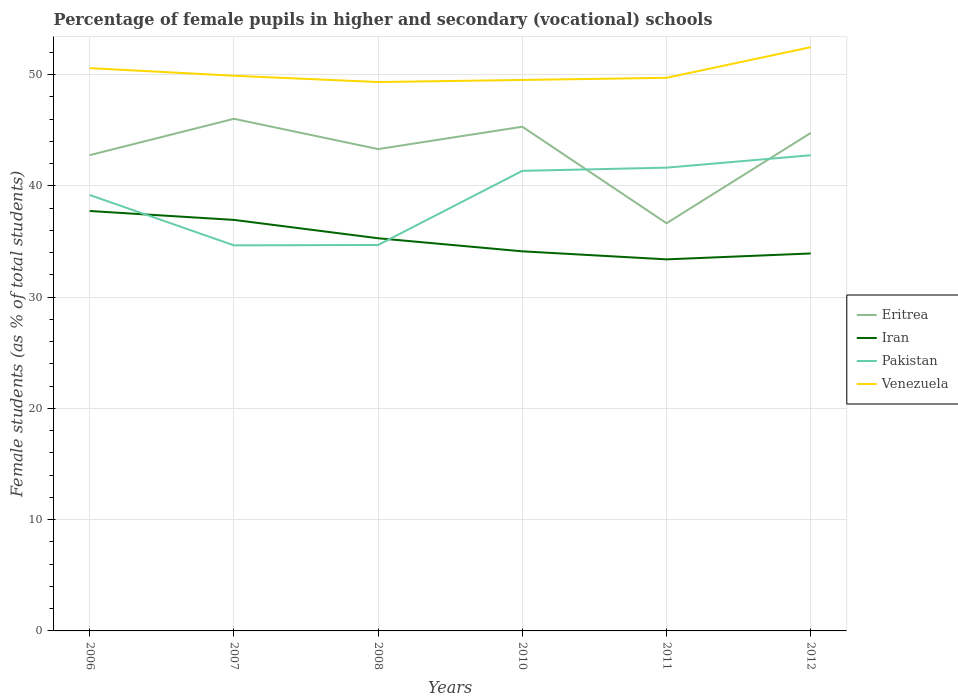Is the number of lines equal to the number of legend labels?
Provide a succinct answer. Yes. Across all years, what is the maximum percentage of female pupils in higher and secondary schools in Venezuela?
Ensure brevity in your answer.  49.34. In which year was the percentage of female pupils in higher and secondary schools in Iran maximum?
Provide a succinct answer. 2011. What is the total percentage of female pupils in higher and secondary schools in Eritrea in the graph?
Your answer should be very brief. 9.39. What is the difference between the highest and the second highest percentage of female pupils in higher and secondary schools in Venezuela?
Offer a terse response. 3.13. What is the difference between the highest and the lowest percentage of female pupils in higher and secondary schools in Eritrea?
Ensure brevity in your answer.  4. How many years are there in the graph?
Offer a very short reply. 6. Does the graph contain any zero values?
Give a very brief answer. No. How are the legend labels stacked?
Make the answer very short. Vertical. What is the title of the graph?
Your answer should be very brief. Percentage of female pupils in higher and secondary (vocational) schools. What is the label or title of the X-axis?
Offer a terse response. Years. What is the label or title of the Y-axis?
Make the answer very short. Female students (as % of total students). What is the Female students (as % of total students) in Eritrea in 2006?
Give a very brief answer. 42.77. What is the Female students (as % of total students) of Iran in 2006?
Provide a succinct answer. 37.75. What is the Female students (as % of total students) of Pakistan in 2006?
Keep it short and to the point. 39.18. What is the Female students (as % of total students) in Venezuela in 2006?
Your answer should be very brief. 50.59. What is the Female students (as % of total students) in Eritrea in 2007?
Your answer should be compact. 46.03. What is the Female students (as % of total students) in Iran in 2007?
Offer a very short reply. 36.95. What is the Female students (as % of total students) in Pakistan in 2007?
Your answer should be very brief. 34.66. What is the Female students (as % of total students) in Venezuela in 2007?
Give a very brief answer. 49.91. What is the Female students (as % of total students) in Eritrea in 2008?
Your answer should be very brief. 43.31. What is the Female students (as % of total students) of Iran in 2008?
Your response must be concise. 35.3. What is the Female students (as % of total students) in Pakistan in 2008?
Your answer should be compact. 34.69. What is the Female students (as % of total students) of Venezuela in 2008?
Make the answer very short. 49.34. What is the Female students (as % of total students) in Eritrea in 2010?
Your response must be concise. 45.32. What is the Female students (as % of total students) of Iran in 2010?
Your response must be concise. 34.12. What is the Female students (as % of total students) of Pakistan in 2010?
Your answer should be very brief. 41.36. What is the Female students (as % of total students) in Venezuela in 2010?
Your answer should be very brief. 49.53. What is the Female students (as % of total students) in Eritrea in 2011?
Your response must be concise. 36.65. What is the Female students (as % of total students) in Iran in 2011?
Provide a short and direct response. 33.4. What is the Female students (as % of total students) in Pakistan in 2011?
Give a very brief answer. 41.64. What is the Female students (as % of total students) in Venezuela in 2011?
Provide a short and direct response. 49.72. What is the Female students (as % of total students) in Eritrea in 2012?
Give a very brief answer. 44.76. What is the Female students (as % of total students) in Iran in 2012?
Keep it short and to the point. 33.93. What is the Female students (as % of total students) of Pakistan in 2012?
Your response must be concise. 42.76. What is the Female students (as % of total students) of Venezuela in 2012?
Keep it short and to the point. 52.47. Across all years, what is the maximum Female students (as % of total students) of Eritrea?
Provide a succinct answer. 46.03. Across all years, what is the maximum Female students (as % of total students) of Iran?
Offer a terse response. 37.75. Across all years, what is the maximum Female students (as % of total students) in Pakistan?
Your answer should be compact. 42.76. Across all years, what is the maximum Female students (as % of total students) in Venezuela?
Keep it short and to the point. 52.47. Across all years, what is the minimum Female students (as % of total students) of Eritrea?
Give a very brief answer. 36.65. Across all years, what is the minimum Female students (as % of total students) of Iran?
Your answer should be compact. 33.4. Across all years, what is the minimum Female students (as % of total students) of Pakistan?
Provide a succinct answer. 34.66. Across all years, what is the minimum Female students (as % of total students) of Venezuela?
Your answer should be very brief. 49.34. What is the total Female students (as % of total students) in Eritrea in the graph?
Provide a succinct answer. 258.84. What is the total Female students (as % of total students) of Iran in the graph?
Offer a terse response. 211.44. What is the total Female students (as % of total students) in Pakistan in the graph?
Provide a succinct answer. 234.29. What is the total Female students (as % of total students) in Venezuela in the graph?
Offer a very short reply. 301.55. What is the difference between the Female students (as % of total students) of Eritrea in 2006 and that in 2007?
Offer a terse response. -3.27. What is the difference between the Female students (as % of total students) of Iran in 2006 and that in 2007?
Offer a terse response. 0.8. What is the difference between the Female students (as % of total students) in Pakistan in 2006 and that in 2007?
Provide a succinct answer. 4.53. What is the difference between the Female students (as % of total students) of Venezuela in 2006 and that in 2007?
Offer a very short reply. 0.68. What is the difference between the Female students (as % of total students) in Eritrea in 2006 and that in 2008?
Ensure brevity in your answer.  -0.54. What is the difference between the Female students (as % of total students) of Iran in 2006 and that in 2008?
Your answer should be compact. 2.45. What is the difference between the Female students (as % of total students) in Pakistan in 2006 and that in 2008?
Provide a short and direct response. 4.49. What is the difference between the Female students (as % of total students) in Venezuela in 2006 and that in 2008?
Offer a terse response. 1.25. What is the difference between the Female students (as % of total students) of Eritrea in 2006 and that in 2010?
Your answer should be very brief. -2.56. What is the difference between the Female students (as % of total students) of Iran in 2006 and that in 2010?
Your answer should be compact. 3.63. What is the difference between the Female students (as % of total students) in Pakistan in 2006 and that in 2010?
Your answer should be very brief. -2.17. What is the difference between the Female students (as % of total students) in Venezuela in 2006 and that in 2010?
Give a very brief answer. 1.06. What is the difference between the Female students (as % of total students) of Eritrea in 2006 and that in 2011?
Give a very brief answer. 6.12. What is the difference between the Female students (as % of total students) in Iran in 2006 and that in 2011?
Keep it short and to the point. 4.35. What is the difference between the Female students (as % of total students) in Pakistan in 2006 and that in 2011?
Keep it short and to the point. -2.46. What is the difference between the Female students (as % of total students) in Venezuela in 2006 and that in 2011?
Your response must be concise. 0.87. What is the difference between the Female students (as % of total students) of Eritrea in 2006 and that in 2012?
Offer a terse response. -1.99. What is the difference between the Female students (as % of total students) of Iran in 2006 and that in 2012?
Your answer should be very brief. 3.82. What is the difference between the Female students (as % of total students) of Pakistan in 2006 and that in 2012?
Offer a very short reply. -3.57. What is the difference between the Female students (as % of total students) of Venezuela in 2006 and that in 2012?
Your answer should be compact. -1.88. What is the difference between the Female students (as % of total students) in Eritrea in 2007 and that in 2008?
Keep it short and to the point. 2.72. What is the difference between the Female students (as % of total students) in Iran in 2007 and that in 2008?
Give a very brief answer. 1.65. What is the difference between the Female students (as % of total students) in Pakistan in 2007 and that in 2008?
Keep it short and to the point. -0.04. What is the difference between the Female students (as % of total students) in Venezuela in 2007 and that in 2008?
Your answer should be compact. 0.57. What is the difference between the Female students (as % of total students) in Eritrea in 2007 and that in 2010?
Ensure brevity in your answer.  0.71. What is the difference between the Female students (as % of total students) in Iran in 2007 and that in 2010?
Give a very brief answer. 2.82. What is the difference between the Female students (as % of total students) in Pakistan in 2007 and that in 2010?
Your answer should be compact. -6.7. What is the difference between the Female students (as % of total students) in Venezuela in 2007 and that in 2010?
Your answer should be very brief. 0.38. What is the difference between the Female students (as % of total students) in Eritrea in 2007 and that in 2011?
Provide a short and direct response. 9.39. What is the difference between the Female students (as % of total students) of Iran in 2007 and that in 2011?
Give a very brief answer. 3.55. What is the difference between the Female students (as % of total students) of Pakistan in 2007 and that in 2011?
Your answer should be compact. -6.99. What is the difference between the Female students (as % of total students) in Venezuela in 2007 and that in 2011?
Provide a short and direct response. 0.19. What is the difference between the Female students (as % of total students) in Eritrea in 2007 and that in 2012?
Provide a succinct answer. 1.27. What is the difference between the Female students (as % of total students) of Iran in 2007 and that in 2012?
Offer a terse response. 3.02. What is the difference between the Female students (as % of total students) of Pakistan in 2007 and that in 2012?
Offer a very short reply. -8.1. What is the difference between the Female students (as % of total students) of Venezuela in 2007 and that in 2012?
Provide a succinct answer. -2.57. What is the difference between the Female students (as % of total students) of Eritrea in 2008 and that in 2010?
Provide a short and direct response. -2.01. What is the difference between the Female students (as % of total students) in Iran in 2008 and that in 2010?
Offer a terse response. 1.17. What is the difference between the Female students (as % of total students) of Pakistan in 2008 and that in 2010?
Your response must be concise. -6.66. What is the difference between the Female students (as % of total students) of Venezuela in 2008 and that in 2010?
Offer a terse response. -0.19. What is the difference between the Female students (as % of total students) in Eritrea in 2008 and that in 2011?
Your answer should be compact. 6.66. What is the difference between the Female students (as % of total students) of Iran in 2008 and that in 2011?
Make the answer very short. 1.9. What is the difference between the Female students (as % of total students) in Pakistan in 2008 and that in 2011?
Provide a short and direct response. -6.95. What is the difference between the Female students (as % of total students) in Venezuela in 2008 and that in 2011?
Offer a terse response. -0.38. What is the difference between the Female students (as % of total students) in Eritrea in 2008 and that in 2012?
Your answer should be very brief. -1.45. What is the difference between the Female students (as % of total students) in Iran in 2008 and that in 2012?
Provide a short and direct response. 1.37. What is the difference between the Female students (as % of total students) in Pakistan in 2008 and that in 2012?
Ensure brevity in your answer.  -8.07. What is the difference between the Female students (as % of total students) in Venezuela in 2008 and that in 2012?
Your answer should be compact. -3.13. What is the difference between the Female students (as % of total students) of Eritrea in 2010 and that in 2011?
Keep it short and to the point. 8.68. What is the difference between the Female students (as % of total students) in Iran in 2010 and that in 2011?
Offer a very short reply. 0.72. What is the difference between the Female students (as % of total students) of Pakistan in 2010 and that in 2011?
Your answer should be very brief. -0.29. What is the difference between the Female students (as % of total students) in Venezuela in 2010 and that in 2011?
Your answer should be compact. -0.19. What is the difference between the Female students (as % of total students) of Eritrea in 2010 and that in 2012?
Give a very brief answer. 0.56. What is the difference between the Female students (as % of total students) in Iran in 2010 and that in 2012?
Make the answer very short. 0.19. What is the difference between the Female students (as % of total students) in Pakistan in 2010 and that in 2012?
Your answer should be compact. -1.4. What is the difference between the Female students (as % of total students) in Venezuela in 2010 and that in 2012?
Your answer should be compact. -2.95. What is the difference between the Female students (as % of total students) in Eritrea in 2011 and that in 2012?
Provide a short and direct response. -8.12. What is the difference between the Female students (as % of total students) in Iran in 2011 and that in 2012?
Provide a short and direct response. -0.53. What is the difference between the Female students (as % of total students) of Pakistan in 2011 and that in 2012?
Your answer should be very brief. -1.12. What is the difference between the Female students (as % of total students) in Venezuela in 2011 and that in 2012?
Give a very brief answer. -2.75. What is the difference between the Female students (as % of total students) of Eritrea in 2006 and the Female students (as % of total students) of Iran in 2007?
Provide a short and direct response. 5.82. What is the difference between the Female students (as % of total students) of Eritrea in 2006 and the Female students (as % of total students) of Pakistan in 2007?
Ensure brevity in your answer.  8.11. What is the difference between the Female students (as % of total students) of Eritrea in 2006 and the Female students (as % of total students) of Venezuela in 2007?
Ensure brevity in your answer.  -7.14. What is the difference between the Female students (as % of total students) of Iran in 2006 and the Female students (as % of total students) of Pakistan in 2007?
Give a very brief answer. 3.09. What is the difference between the Female students (as % of total students) of Iran in 2006 and the Female students (as % of total students) of Venezuela in 2007?
Ensure brevity in your answer.  -12.16. What is the difference between the Female students (as % of total students) in Pakistan in 2006 and the Female students (as % of total students) in Venezuela in 2007?
Provide a succinct answer. -10.72. What is the difference between the Female students (as % of total students) of Eritrea in 2006 and the Female students (as % of total students) of Iran in 2008?
Provide a succinct answer. 7.47. What is the difference between the Female students (as % of total students) of Eritrea in 2006 and the Female students (as % of total students) of Pakistan in 2008?
Give a very brief answer. 8.07. What is the difference between the Female students (as % of total students) of Eritrea in 2006 and the Female students (as % of total students) of Venezuela in 2008?
Give a very brief answer. -6.57. What is the difference between the Female students (as % of total students) in Iran in 2006 and the Female students (as % of total students) in Pakistan in 2008?
Make the answer very short. 3.05. What is the difference between the Female students (as % of total students) in Iran in 2006 and the Female students (as % of total students) in Venezuela in 2008?
Ensure brevity in your answer.  -11.59. What is the difference between the Female students (as % of total students) in Pakistan in 2006 and the Female students (as % of total students) in Venezuela in 2008?
Offer a very short reply. -10.15. What is the difference between the Female students (as % of total students) in Eritrea in 2006 and the Female students (as % of total students) in Iran in 2010?
Provide a succinct answer. 8.65. What is the difference between the Female students (as % of total students) in Eritrea in 2006 and the Female students (as % of total students) in Pakistan in 2010?
Offer a terse response. 1.41. What is the difference between the Female students (as % of total students) of Eritrea in 2006 and the Female students (as % of total students) of Venezuela in 2010?
Your answer should be compact. -6.76. What is the difference between the Female students (as % of total students) of Iran in 2006 and the Female students (as % of total students) of Pakistan in 2010?
Your answer should be compact. -3.61. What is the difference between the Female students (as % of total students) in Iran in 2006 and the Female students (as % of total students) in Venezuela in 2010?
Give a very brief answer. -11.78. What is the difference between the Female students (as % of total students) of Pakistan in 2006 and the Female students (as % of total students) of Venezuela in 2010?
Keep it short and to the point. -10.34. What is the difference between the Female students (as % of total students) in Eritrea in 2006 and the Female students (as % of total students) in Iran in 2011?
Offer a terse response. 9.37. What is the difference between the Female students (as % of total students) of Eritrea in 2006 and the Female students (as % of total students) of Pakistan in 2011?
Your response must be concise. 1.12. What is the difference between the Female students (as % of total students) in Eritrea in 2006 and the Female students (as % of total students) in Venezuela in 2011?
Offer a terse response. -6.95. What is the difference between the Female students (as % of total students) of Iran in 2006 and the Female students (as % of total students) of Pakistan in 2011?
Give a very brief answer. -3.9. What is the difference between the Female students (as % of total students) of Iran in 2006 and the Female students (as % of total students) of Venezuela in 2011?
Your answer should be compact. -11.97. What is the difference between the Female students (as % of total students) in Pakistan in 2006 and the Female students (as % of total students) in Venezuela in 2011?
Your response must be concise. -10.53. What is the difference between the Female students (as % of total students) in Eritrea in 2006 and the Female students (as % of total students) in Iran in 2012?
Ensure brevity in your answer.  8.84. What is the difference between the Female students (as % of total students) of Eritrea in 2006 and the Female students (as % of total students) of Pakistan in 2012?
Provide a succinct answer. 0.01. What is the difference between the Female students (as % of total students) in Eritrea in 2006 and the Female students (as % of total students) in Venezuela in 2012?
Your response must be concise. -9.7. What is the difference between the Female students (as % of total students) in Iran in 2006 and the Female students (as % of total students) in Pakistan in 2012?
Your answer should be very brief. -5.01. What is the difference between the Female students (as % of total students) of Iran in 2006 and the Female students (as % of total students) of Venezuela in 2012?
Keep it short and to the point. -14.73. What is the difference between the Female students (as % of total students) of Pakistan in 2006 and the Female students (as % of total students) of Venezuela in 2012?
Your answer should be very brief. -13.29. What is the difference between the Female students (as % of total students) of Eritrea in 2007 and the Female students (as % of total students) of Iran in 2008?
Provide a short and direct response. 10.74. What is the difference between the Female students (as % of total students) in Eritrea in 2007 and the Female students (as % of total students) in Pakistan in 2008?
Make the answer very short. 11.34. What is the difference between the Female students (as % of total students) of Eritrea in 2007 and the Female students (as % of total students) of Venezuela in 2008?
Make the answer very short. -3.3. What is the difference between the Female students (as % of total students) in Iran in 2007 and the Female students (as % of total students) in Pakistan in 2008?
Keep it short and to the point. 2.25. What is the difference between the Female students (as % of total students) in Iran in 2007 and the Female students (as % of total students) in Venezuela in 2008?
Your answer should be very brief. -12.39. What is the difference between the Female students (as % of total students) in Pakistan in 2007 and the Female students (as % of total students) in Venezuela in 2008?
Ensure brevity in your answer.  -14.68. What is the difference between the Female students (as % of total students) of Eritrea in 2007 and the Female students (as % of total students) of Iran in 2010?
Offer a very short reply. 11.91. What is the difference between the Female students (as % of total students) in Eritrea in 2007 and the Female students (as % of total students) in Pakistan in 2010?
Make the answer very short. 4.68. What is the difference between the Female students (as % of total students) in Eritrea in 2007 and the Female students (as % of total students) in Venezuela in 2010?
Offer a very short reply. -3.49. What is the difference between the Female students (as % of total students) in Iran in 2007 and the Female students (as % of total students) in Pakistan in 2010?
Keep it short and to the point. -4.41. What is the difference between the Female students (as % of total students) in Iran in 2007 and the Female students (as % of total students) in Venezuela in 2010?
Offer a very short reply. -12.58. What is the difference between the Female students (as % of total students) in Pakistan in 2007 and the Female students (as % of total students) in Venezuela in 2010?
Your response must be concise. -14.87. What is the difference between the Female students (as % of total students) of Eritrea in 2007 and the Female students (as % of total students) of Iran in 2011?
Your response must be concise. 12.64. What is the difference between the Female students (as % of total students) in Eritrea in 2007 and the Female students (as % of total students) in Pakistan in 2011?
Make the answer very short. 4.39. What is the difference between the Female students (as % of total students) in Eritrea in 2007 and the Female students (as % of total students) in Venezuela in 2011?
Your answer should be very brief. -3.68. What is the difference between the Female students (as % of total students) in Iran in 2007 and the Female students (as % of total students) in Pakistan in 2011?
Make the answer very short. -4.7. What is the difference between the Female students (as % of total students) of Iran in 2007 and the Female students (as % of total students) of Venezuela in 2011?
Your answer should be compact. -12.77. What is the difference between the Female students (as % of total students) in Pakistan in 2007 and the Female students (as % of total students) in Venezuela in 2011?
Offer a terse response. -15.06. What is the difference between the Female students (as % of total students) in Eritrea in 2007 and the Female students (as % of total students) in Iran in 2012?
Offer a terse response. 12.11. What is the difference between the Female students (as % of total students) of Eritrea in 2007 and the Female students (as % of total students) of Pakistan in 2012?
Ensure brevity in your answer.  3.28. What is the difference between the Female students (as % of total students) of Eritrea in 2007 and the Female students (as % of total students) of Venezuela in 2012?
Your response must be concise. -6.44. What is the difference between the Female students (as % of total students) of Iran in 2007 and the Female students (as % of total students) of Pakistan in 2012?
Provide a short and direct response. -5.81. What is the difference between the Female students (as % of total students) in Iran in 2007 and the Female students (as % of total students) in Venezuela in 2012?
Provide a succinct answer. -15.53. What is the difference between the Female students (as % of total students) in Pakistan in 2007 and the Female students (as % of total students) in Venezuela in 2012?
Your answer should be very brief. -17.81. What is the difference between the Female students (as % of total students) in Eritrea in 2008 and the Female students (as % of total students) in Iran in 2010?
Your answer should be compact. 9.19. What is the difference between the Female students (as % of total students) of Eritrea in 2008 and the Female students (as % of total students) of Pakistan in 2010?
Your response must be concise. 1.96. What is the difference between the Female students (as % of total students) of Eritrea in 2008 and the Female students (as % of total students) of Venezuela in 2010?
Offer a terse response. -6.21. What is the difference between the Female students (as % of total students) in Iran in 2008 and the Female students (as % of total students) in Pakistan in 2010?
Your response must be concise. -6.06. What is the difference between the Female students (as % of total students) in Iran in 2008 and the Female students (as % of total students) in Venezuela in 2010?
Ensure brevity in your answer.  -14.23. What is the difference between the Female students (as % of total students) in Pakistan in 2008 and the Female students (as % of total students) in Venezuela in 2010?
Offer a terse response. -14.83. What is the difference between the Female students (as % of total students) of Eritrea in 2008 and the Female students (as % of total students) of Iran in 2011?
Provide a short and direct response. 9.91. What is the difference between the Female students (as % of total students) in Eritrea in 2008 and the Female students (as % of total students) in Pakistan in 2011?
Your answer should be very brief. 1.67. What is the difference between the Female students (as % of total students) of Eritrea in 2008 and the Female students (as % of total students) of Venezuela in 2011?
Provide a short and direct response. -6.41. What is the difference between the Female students (as % of total students) of Iran in 2008 and the Female students (as % of total students) of Pakistan in 2011?
Provide a short and direct response. -6.35. What is the difference between the Female students (as % of total students) of Iran in 2008 and the Female students (as % of total students) of Venezuela in 2011?
Keep it short and to the point. -14.42. What is the difference between the Female students (as % of total students) of Pakistan in 2008 and the Female students (as % of total students) of Venezuela in 2011?
Ensure brevity in your answer.  -15.03. What is the difference between the Female students (as % of total students) of Eritrea in 2008 and the Female students (as % of total students) of Iran in 2012?
Your response must be concise. 9.38. What is the difference between the Female students (as % of total students) of Eritrea in 2008 and the Female students (as % of total students) of Pakistan in 2012?
Offer a very short reply. 0.55. What is the difference between the Female students (as % of total students) of Eritrea in 2008 and the Female students (as % of total students) of Venezuela in 2012?
Offer a very short reply. -9.16. What is the difference between the Female students (as % of total students) of Iran in 2008 and the Female students (as % of total students) of Pakistan in 2012?
Make the answer very short. -7.46. What is the difference between the Female students (as % of total students) in Iran in 2008 and the Female students (as % of total students) in Venezuela in 2012?
Make the answer very short. -17.18. What is the difference between the Female students (as % of total students) in Pakistan in 2008 and the Female students (as % of total students) in Venezuela in 2012?
Your answer should be very brief. -17.78. What is the difference between the Female students (as % of total students) in Eritrea in 2010 and the Female students (as % of total students) in Iran in 2011?
Keep it short and to the point. 11.92. What is the difference between the Female students (as % of total students) in Eritrea in 2010 and the Female students (as % of total students) in Pakistan in 2011?
Give a very brief answer. 3.68. What is the difference between the Female students (as % of total students) of Eritrea in 2010 and the Female students (as % of total students) of Venezuela in 2011?
Your answer should be very brief. -4.4. What is the difference between the Female students (as % of total students) in Iran in 2010 and the Female students (as % of total students) in Pakistan in 2011?
Keep it short and to the point. -7.52. What is the difference between the Female students (as % of total students) in Iran in 2010 and the Female students (as % of total students) in Venezuela in 2011?
Provide a short and direct response. -15.6. What is the difference between the Female students (as % of total students) of Pakistan in 2010 and the Female students (as % of total students) of Venezuela in 2011?
Provide a succinct answer. -8.36. What is the difference between the Female students (as % of total students) of Eritrea in 2010 and the Female students (as % of total students) of Iran in 2012?
Your answer should be very brief. 11.39. What is the difference between the Female students (as % of total students) of Eritrea in 2010 and the Female students (as % of total students) of Pakistan in 2012?
Offer a terse response. 2.56. What is the difference between the Female students (as % of total students) in Eritrea in 2010 and the Female students (as % of total students) in Venezuela in 2012?
Make the answer very short. -7.15. What is the difference between the Female students (as % of total students) of Iran in 2010 and the Female students (as % of total students) of Pakistan in 2012?
Your response must be concise. -8.64. What is the difference between the Female students (as % of total students) in Iran in 2010 and the Female students (as % of total students) in Venezuela in 2012?
Make the answer very short. -18.35. What is the difference between the Female students (as % of total students) in Pakistan in 2010 and the Female students (as % of total students) in Venezuela in 2012?
Keep it short and to the point. -11.12. What is the difference between the Female students (as % of total students) of Eritrea in 2011 and the Female students (as % of total students) of Iran in 2012?
Your response must be concise. 2.72. What is the difference between the Female students (as % of total students) in Eritrea in 2011 and the Female students (as % of total students) in Pakistan in 2012?
Make the answer very short. -6.11. What is the difference between the Female students (as % of total students) of Eritrea in 2011 and the Female students (as % of total students) of Venezuela in 2012?
Your answer should be compact. -15.82. What is the difference between the Female students (as % of total students) of Iran in 2011 and the Female students (as % of total students) of Pakistan in 2012?
Provide a short and direct response. -9.36. What is the difference between the Female students (as % of total students) in Iran in 2011 and the Female students (as % of total students) in Venezuela in 2012?
Offer a very short reply. -19.07. What is the difference between the Female students (as % of total students) of Pakistan in 2011 and the Female students (as % of total students) of Venezuela in 2012?
Your answer should be compact. -10.83. What is the average Female students (as % of total students) in Eritrea per year?
Make the answer very short. 43.14. What is the average Female students (as % of total students) in Iran per year?
Make the answer very short. 35.24. What is the average Female students (as % of total students) of Pakistan per year?
Offer a very short reply. 39.05. What is the average Female students (as % of total students) in Venezuela per year?
Ensure brevity in your answer.  50.26. In the year 2006, what is the difference between the Female students (as % of total students) of Eritrea and Female students (as % of total students) of Iran?
Offer a terse response. 5.02. In the year 2006, what is the difference between the Female students (as % of total students) of Eritrea and Female students (as % of total students) of Pakistan?
Your response must be concise. 3.58. In the year 2006, what is the difference between the Female students (as % of total students) in Eritrea and Female students (as % of total students) in Venezuela?
Provide a short and direct response. -7.82. In the year 2006, what is the difference between the Female students (as % of total students) in Iran and Female students (as % of total students) in Pakistan?
Your answer should be very brief. -1.44. In the year 2006, what is the difference between the Female students (as % of total students) in Iran and Female students (as % of total students) in Venezuela?
Keep it short and to the point. -12.84. In the year 2006, what is the difference between the Female students (as % of total students) in Pakistan and Female students (as % of total students) in Venezuela?
Ensure brevity in your answer.  -11.4. In the year 2007, what is the difference between the Female students (as % of total students) in Eritrea and Female students (as % of total students) in Iran?
Provide a succinct answer. 9.09. In the year 2007, what is the difference between the Female students (as % of total students) of Eritrea and Female students (as % of total students) of Pakistan?
Your response must be concise. 11.38. In the year 2007, what is the difference between the Female students (as % of total students) of Eritrea and Female students (as % of total students) of Venezuela?
Offer a very short reply. -3.87. In the year 2007, what is the difference between the Female students (as % of total students) in Iran and Female students (as % of total students) in Pakistan?
Your answer should be compact. 2.29. In the year 2007, what is the difference between the Female students (as % of total students) in Iran and Female students (as % of total students) in Venezuela?
Provide a succinct answer. -12.96. In the year 2007, what is the difference between the Female students (as % of total students) of Pakistan and Female students (as % of total students) of Venezuela?
Give a very brief answer. -15.25. In the year 2008, what is the difference between the Female students (as % of total students) in Eritrea and Female students (as % of total students) in Iran?
Provide a short and direct response. 8.02. In the year 2008, what is the difference between the Female students (as % of total students) in Eritrea and Female students (as % of total students) in Pakistan?
Your response must be concise. 8.62. In the year 2008, what is the difference between the Female students (as % of total students) in Eritrea and Female students (as % of total students) in Venezuela?
Provide a succinct answer. -6.03. In the year 2008, what is the difference between the Female students (as % of total students) in Iran and Female students (as % of total students) in Pakistan?
Provide a succinct answer. 0.6. In the year 2008, what is the difference between the Female students (as % of total students) in Iran and Female students (as % of total students) in Venezuela?
Ensure brevity in your answer.  -14.04. In the year 2008, what is the difference between the Female students (as % of total students) of Pakistan and Female students (as % of total students) of Venezuela?
Provide a succinct answer. -14.64. In the year 2010, what is the difference between the Female students (as % of total students) of Eritrea and Female students (as % of total students) of Iran?
Provide a short and direct response. 11.2. In the year 2010, what is the difference between the Female students (as % of total students) of Eritrea and Female students (as % of total students) of Pakistan?
Provide a succinct answer. 3.97. In the year 2010, what is the difference between the Female students (as % of total students) in Eritrea and Female students (as % of total students) in Venezuela?
Your answer should be compact. -4.2. In the year 2010, what is the difference between the Female students (as % of total students) in Iran and Female students (as % of total students) in Pakistan?
Your answer should be very brief. -7.23. In the year 2010, what is the difference between the Female students (as % of total students) of Iran and Female students (as % of total students) of Venezuela?
Make the answer very short. -15.41. In the year 2010, what is the difference between the Female students (as % of total students) in Pakistan and Female students (as % of total students) in Venezuela?
Offer a terse response. -8.17. In the year 2011, what is the difference between the Female students (as % of total students) in Eritrea and Female students (as % of total students) in Iran?
Keep it short and to the point. 3.25. In the year 2011, what is the difference between the Female students (as % of total students) of Eritrea and Female students (as % of total students) of Pakistan?
Your answer should be compact. -5. In the year 2011, what is the difference between the Female students (as % of total students) of Eritrea and Female students (as % of total students) of Venezuela?
Your answer should be very brief. -13.07. In the year 2011, what is the difference between the Female students (as % of total students) of Iran and Female students (as % of total students) of Pakistan?
Give a very brief answer. -8.24. In the year 2011, what is the difference between the Female students (as % of total students) of Iran and Female students (as % of total students) of Venezuela?
Your response must be concise. -16.32. In the year 2011, what is the difference between the Female students (as % of total students) of Pakistan and Female students (as % of total students) of Venezuela?
Your answer should be very brief. -8.08. In the year 2012, what is the difference between the Female students (as % of total students) of Eritrea and Female students (as % of total students) of Iran?
Provide a short and direct response. 10.83. In the year 2012, what is the difference between the Female students (as % of total students) in Eritrea and Female students (as % of total students) in Pakistan?
Your answer should be very brief. 2. In the year 2012, what is the difference between the Female students (as % of total students) in Eritrea and Female students (as % of total students) in Venezuela?
Provide a succinct answer. -7.71. In the year 2012, what is the difference between the Female students (as % of total students) in Iran and Female students (as % of total students) in Pakistan?
Your answer should be compact. -8.83. In the year 2012, what is the difference between the Female students (as % of total students) of Iran and Female students (as % of total students) of Venezuela?
Your answer should be very brief. -18.54. In the year 2012, what is the difference between the Female students (as % of total students) in Pakistan and Female students (as % of total students) in Venezuela?
Ensure brevity in your answer.  -9.71. What is the ratio of the Female students (as % of total students) in Eritrea in 2006 to that in 2007?
Your response must be concise. 0.93. What is the ratio of the Female students (as % of total students) in Iran in 2006 to that in 2007?
Ensure brevity in your answer.  1.02. What is the ratio of the Female students (as % of total students) of Pakistan in 2006 to that in 2007?
Your answer should be compact. 1.13. What is the ratio of the Female students (as % of total students) of Venezuela in 2006 to that in 2007?
Offer a very short reply. 1.01. What is the ratio of the Female students (as % of total students) in Eritrea in 2006 to that in 2008?
Your response must be concise. 0.99. What is the ratio of the Female students (as % of total students) in Iran in 2006 to that in 2008?
Offer a terse response. 1.07. What is the ratio of the Female students (as % of total students) of Pakistan in 2006 to that in 2008?
Ensure brevity in your answer.  1.13. What is the ratio of the Female students (as % of total students) in Venezuela in 2006 to that in 2008?
Offer a very short reply. 1.03. What is the ratio of the Female students (as % of total students) in Eritrea in 2006 to that in 2010?
Your answer should be compact. 0.94. What is the ratio of the Female students (as % of total students) of Iran in 2006 to that in 2010?
Provide a short and direct response. 1.11. What is the ratio of the Female students (as % of total students) in Pakistan in 2006 to that in 2010?
Offer a very short reply. 0.95. What is the ratio of the Female students (as % of total students) of Venezuela in 2006 to that in 2010?
Your answer should be very brief. 1.02. What is the ratio of the Female students (as % of total students) of Eritrea in 2006 to that in 2011?
Keep it short and to the point. 1.17. What is the ratio of the Female students (as % of total students) in Iran in 2006 to that in 2011?
Offer a very short reply. 1.13. What is the ratio of the Female students (as % of total students) in Pakistan in 2006 to that in 2011?
Provide a short and direct response. 0.94. What is the ratio of the Female students (as % of total students) in Venezuela in 2006 to that in 2011?
Your response must be concise. 1.02. What is the ratio of the Female students (as % of total students) in Eritrea in 2006 to that in 2012?
Your answer should be very brief. 0.96. What is the ratio of the Female students (as % of total students) of Iran in 2006 to that in 2012?
Your answer should be very brief. 1.11. What is the ratio of the Female students (as % of total students) of Pakistan in 2006 to that in 2012?
Offer a terse response. 0.92. What is the ratio of the Female students (as % of total students) in Venezuela in 2006 to that in 2012?
Make the answer very short. 0.96. What is the ratio of the Female students (as % of total students) of Eritrea in 2007 to that in 2008?
Offer a terse response. 1.06. What is the ratio of the Female students (as % of total students) of Iran in 2007 to that in 2008?
Offer a terse response. 1.05. What is the ratio of the Female students (as % of total students) in Venezuela in 2007 to that in 2008?
Your answer should be compact. 1.01. What is the ratio of the Female students (as % of total students) in Eritrea in 2007 to that in 2010?
Offer a very short reply. 1.02. What is the ratio of the Female students (as % of total students) in Iran in 2007 to that in 2010?
Keep it short and to the point. 1.08. What is the ratio of the Female students (as % of total students) of Pakistan in 2007 to that in 2010?
Give a very brief answer. 0.84. What is the ratio of the Female students (as % of total students) in Venezuela in 2007 to that in 2010?
Offer a terse response. 1.01. What is the ratio of the Female students (as % of total students) in Eritrea in 2007 to that in 2011?
Make the answer very short. 1.26. What is the ratio of the Female students (as % of total students) in Iran in 2007 to that in 2011?
Your response must be concise. 1.11. What is the ratio of the Female students (as % of total students) in Pakistan in 2007 to that in 2011?
Ensure brevity in your answer.  0.83. What is the ratio of the Female students (as % of total students) of Venezuela in 2007 to that in 2011?
Offer a terse response. 1. What is the ratio of the Female students (as % of total students) in Eritrea in 2007 to that in 2012?
Your answer should be very brief. 1.03. What is the ratio of the Female students (as % of total students) in Iran in 2007 to that in 2012?
Ensure brevity in your answer.  1.09. What is the ratio of the Female students (as % of total students) of Pakistan in 2007 to that in 2012?
Your answer should be very brief. 0.81. What is the ratio of the Female students (as % of total students) of Venezuela in 2007 to that in 2012?
Give a very brief answer. 0.95. What is the ratio of the Female students (as % of total students) in Eritrea in 2008 to that in 2010?
Give a very brief answer. 0.96. What is the ratio of the Female students (as % of total students) of Iran in 2008 to that in 2010?
Make the answer very short. 1.03. What is the ratio of the Female students (as % of total students) of Pakistan in 2008 to that in 2010?
Ensure brevity in your answer.  0.84. What is the ratio of the Female students (as % of total students) in Venezuela in 2008 to that in 2010?
Your response must be concise. 1. What is the ratio of the Female students (as % of total students) in Eritrea in 2008 to that in 2011?
Provide a short and direct response. 1.18. What is the ratio of the Female students (as % of total students) of Iran in 2008 to that in 2011?
Your response must be concise. 1.06. What is the ratio of the Female students (as % of total students) in Pakistan in 2008 to that in 2011?
Ensure brevity in your answer.  0.83. What is the ratio of the Female students (as % of total students) in Venezuela in 2008 to that in 2011?
Your response must be concise. 0.99. What is the ratio of the Female students (as % of total students) of Eritrea in 2008 to that in 2012?
Your answer should be compact. 0.97. What is the ratio of the Female students (as % of total students) in Iran in 2008 to that in 2012?
Provide a short and direct response. 1.04. What is the ratio of the Female students (as % of total students) of Pakistan in 2008 to that in 2012?
Provide a succinct answer. 0.81. What is the ratio of the Female students (as % of total students) in Venezuela in 2008 to that in 2012?
Offer a very short reply. 0.94. What is the ratio of the Female students (as % of total students) in Eritrea in 2010 to that in 2011?
Offer a terse response. 1.24. What is the ratio of the Female students (as % of total students) in Iran in 2010 to that in 2011?
Your answer should be compact. 1.02. What is the ratio of the Female students (as % of total students) in Venezuela in 2010 to that in 2011?
Offer a terse response. 1. What is the ratio of the Female students (as % of total students) of Eritrea in 2010 to that in 2012?
Your response must be concise. 1.01. What is the ratio of the Female students (as % of total students) of Iran in 2010 to that in 2012?
Keep it short and to the point. 1.01. What is the ratio of the Female students (as % of total students) of Pakistan in 2010 to that in 2012?
Your response must be concise. 0.97. What is the ratio of the Female students (as % of total students) of Venezuela in 2010 to that in 2012?
Ensure brevity in your answer.  0.94. What is the ratio of the Female students (as % of total students) in Eritrea in 2011 to that in 2012?
Offer a terse response. 0.82. What is the ratio of the Female students (as % of total students) of Iran in 2011 to that in 2012?
Your answer should be compact. 0.98. What is the ratio of the Female students (as % of total students) of Pakistan in 2011 to that in 2012?
Your answer should be compact. 0.97. What is the ratio of the Female students (as % of total students) of Venezuela in 2011 to that in 2012?
Provide a succinct answer. 0.95. What is the difference between the highest and the second highest Female students (as % of total students) of Eritrea?
Keep it short and to the point. 0.71. What is the difference between the highest and the second highest Female students (as % of total students) of Iran?
Offer a very short reply. 0.8. What is the difference between the highest and the second highest Female students (as % of total students) in Pakistan?
Provide a short and direct response. 1.12. What is the difference between the highest and the second highest Female students (as % of total students) in Venezuela?
Make the answer very short. 1.88. What is the difference between the highest and the lowest Female students (as % of total students) in Eritrea?
Make the answer very short. 9.39. What is the difference between the highest and the lowest Female students (as % of total students) of Iran?
Make the answer very short. 4.35. What is the difference between the highest and the lowest Female students (as % of total students) of Pakistan?
Provide a succinct answer. 8.1. What is the difference between the highest and the lowest Female students (as % of total students) of Venezuela?
Give a very brief answer. 3.13. 